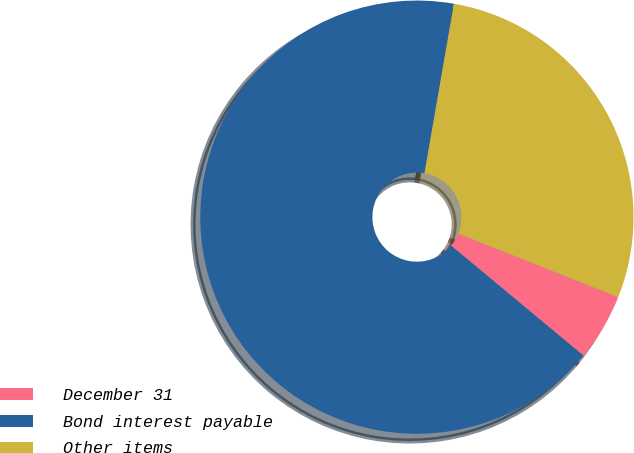Convert chart. <chart><loc_0><loc_0><loc_500><loc_500><pie_chart><fcel>December 31<fcel>Bond interest payable<fcel>Other items<nl><fcel>5.02%<fcel>66.71%<fcel>28.28%<nl></chart> 